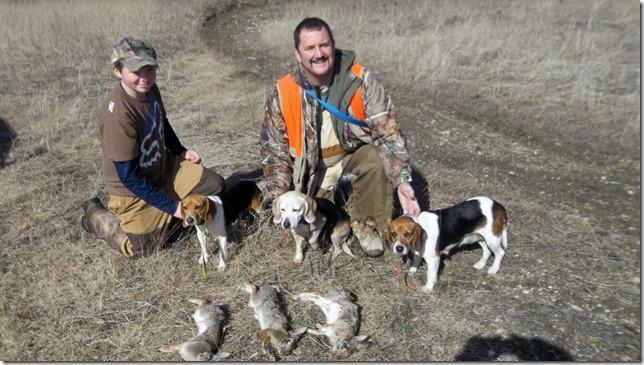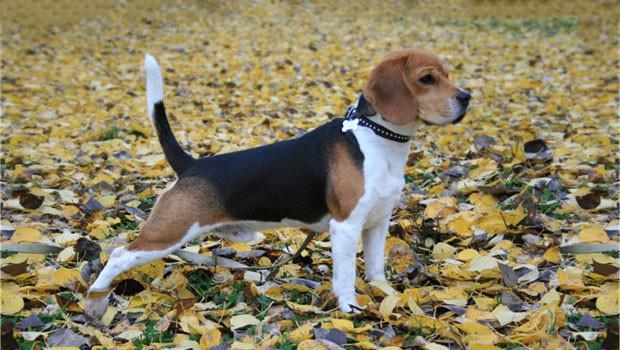The first image is the image on the left, the second image is the image on the right. For the images shown, is this caption "There is a single person standing with a group of dogs in one of the images." true? Answer yes or no. No. The first image is the image on the left, the second image is the image on the right. For the images shown, is this caption "At least one of the images contains one or more rabbits." true? Answer yes or no. Yes. The first image is the image on the left, the second image is the image on the right. For the images displayed, is the sentence "1 dog has a tail that is sticking up." factually correct? Answer yes or no. Yes. The first image is the image on the left, the second image is the image on the right. For the images shown, is this caption "At least one of the images shows only one dog." true? Answer yes or no. Yes. 